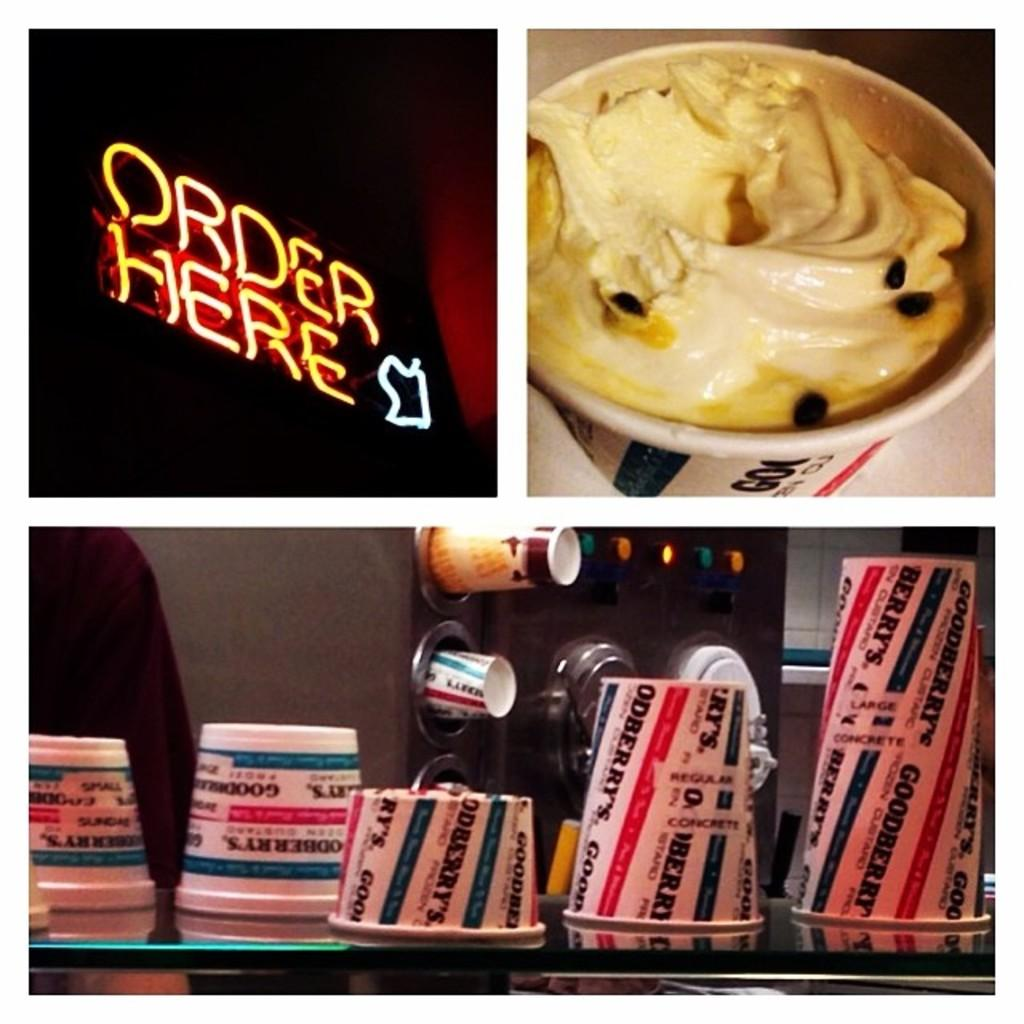<image>
Summarize the visual content of the image. the word order is on the bright sign 